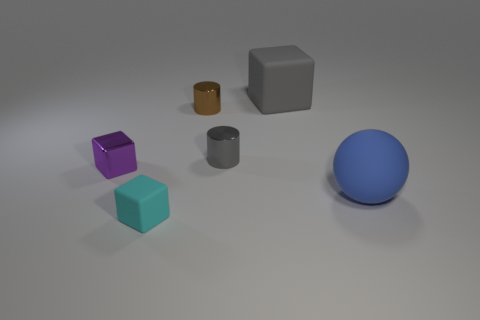Subtract all rubber cubes. How many cubes are left? 1 Subtract 1 cubes. How many cubes are left? 2 Subtract all gray cylinders. How many cylinders are left? 1 Subtract all balls. How many objects are left? 5 Subtract all gray spheres. Subtract all cyan cylinders. How many spheres are left? 1 Subtract all large balls. Subtract all tiny cylinders. How many objects are left? 3 Add 4 cyan matte objects. How many cyan matte objects are left? 5 Add 6 small brown blocks. How many small brown blocks exist? 6 Add 2 tiny rubber blocks. How many objects exist? 8 Subtract 0 red spheres. How many objects are left? 6 